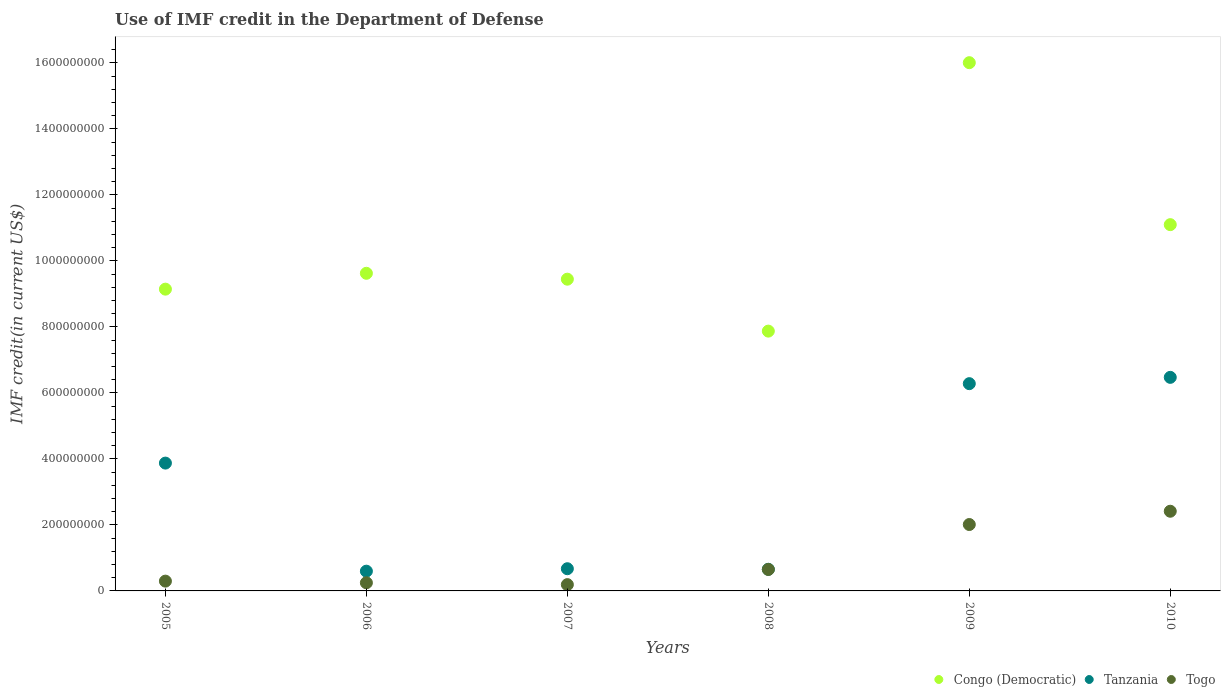What is the IMF credit in the Department of Defense in Togo in 2007?
Your response must be concise. 1.91e+07. Across all years, what is the maximum IMF credit in the Department of Defense in Congo (Democratic)?
Make the answer very short. 1.60e+09. Across all years, what is the minimum IMF credit in the Department of Defense in Togo?
Provide a short and direct response. 1.91e+07. In which year was the IMF credit in the Department of Defense in Tanzania maximum?
Keep it short and to the point. 2010. In which year was the IMF credit in the Department of Defense in Togo minimum?
Provide a succinct answer. 2007. What is the total IMF credit in the Department of Defense in Tanzania in the graph?
Your response must be concise. 1.86e+09. What is the difference between the IMF credit in the Department of Defense in Togo in 2007 and that in 2008?
Your answer should be very brief. -4.60e+07. What is the difference between the IMF credit in the Department of Defense in Togo in 2009 and the IMF credit in the Department of Defense in Tanzania in 2008?
Provide a succinct answer. 1.36e+08. What is the average IMF credit in the Department of Defense in Tanzania per year?
Your answer should be compact. 3.09e+08. In the year 2006, what is the difference between the IMF credit in the Department of Defense in Tanzania and IMF credit in the Department of Defense in Togo?
Your answer should be very brief. 3.52e+07. What is the ratio of the IMF credit in the Department of Defense in Congo (Democratic) in 2007 to that in 2010?
Provide a short and direct response. 0.85. Is the difference between the IMF credit in the Department of Defense in Tanzania in 2006 and 2007 greater than the difference between the IMF credit in the Department of Defense in Togo in 2006 and 2007?
Your response must be concise. No. What is the difference between the highest and the second highest IMF credit in the Department of Defense in Congo (Democratic)?
Offer a very short reply. 4.91e+08. What is the difference between the highest and the lowest IMF credit in the Department of Defense in Tanzania?
Offer a terse response. 5.87e+08. Is the sum of the IMF credit in the Department of Defense in Congo (Democratic) in 2005 and 2006 greater than the maximum IMF credit in the Department of Defense in Tanzania across all years?
Ensure brevity in your answer.  Yes. Is it the case that in every year, the sum of the IMF credit in the Department of Defense in Togo and IMF credit in the Department of Defense in Congo (Democratic)  is greater than the IMF credit in the Department of Defense in Tanzania?
Your response must be concise. Yes. How many dotlines are there?
Your response must be concise. 3. How many years are there in the graph?
Your response must be concise. 6. Does the graph contain any zero values?
Provide a short and direct response. No. Where does the legend appear in the graph?
Offer a terse response. Bottom right. How many legend labels are there?
Your response must be concise. 3. What is the title of the graph?
Offer a terse response. Use of IMF credit in the Department of Defense. Does "Guinea-Bissau" appear as one of the legend labels in the graph?
Your answer should be very brief. No. What is the label or title of the Y-axis?
Make the answer very short. IMF credit(in current US$). What is the IMF credit(in current US$) in Congo (Democratic) in 2005?
Offer a very short reply. 9.14e+08. What is the IMF credit(in current US$) of Tanzania in 2005?
Offer a terse response. 3.87e+08. What is the IMF credit(in current US$) in Togo in 2005?
Your response must be concise. 2.97e+07. What is the IMF credit(in current US$) of Congo (Democratic) in 2006?
Give a very brief answer. 9.62e+08. What is the IMF credit(in current US$) of Tanzania in 2006?
Offer a very short reply. 5.98e+07. What is the IMF credit(in current US$) of Togo in 2006?
Offer a terse response. 2.47e+07. What is the IMF credit(in current US$) of Congo (Democratic) in 2007?
Ensure brevity in your answer.  9.45e+08. What is the IMF credit(in current US$) in Tanzania in 2007?
Provide a succinct answer. 6.73e+07. What is the IMF credit(in current US$) in Togo in 2007?
Your answer should be compact. 1.91e+07. What is the IMF credit(in current US$) of Congo (Democratic) in 2008?
Offer a very short reply. 7.87e+08. What is the IMF credit(in current US$) of Tanzania in 2008?
Provide a short and direct response. 6.56e+07. What is the IMF credit(in current US$) in Togo in 2008?
Your answer should be compact. 6.50e+07. What is the IMF credit(in current US$) of Congo (Democratic) in 2009?
Offer a very short reply. 1.60e+09. What is the IMF credit(in current US$) of Tanzania in 2009?
Your response must be concise. 6.28e+08. What is the IMF credit(in current US$) of Togo in 2009?
Make the answer very short. 2.01e+08. What is the IMF credit(in current US$) in Congo (Democratic) in 2010?
Offer a terse response. 1.11e+09. What is the IMF credit(in current US$) in Tanzania in 2010?
Provide a short and direct response. 6.47e+08. What is the IMF credit(in current US$) of Togo in 2010?
Provide a succinct answer. 2.41e+08. Across all years, what is the maximum IMF credit(in current US$) of Congo (Democratic)?
Offer a very short reply. 1.60e+09. Across all years, what is the maximum IMF credit(in current US$) of Tanzania?
Ensure brevity in your answer.  6.47e+08. Across all years, what is the maximum IMF credit(in current US$) of Togo?
Your answer should be compact. 2.41e+08. Across all years, what is the minimum IMF credit(in current US$) of Congo (Democratic)?
Offer a very short reply. 7.87e+08. Across all years, what is the minimum IMF credit(in current US$) of Tanzania?
Your answer should be very brief. 5.98e+07. Across all years, what is the minimum IMF credit(in current US$) of Togo?
Keep it short and to the point. 1.91e+07. What is the total IMF credit(in current US$) of Congo (Democratic) in the graph?
Your answer should be very brief. 6.32e+09. What is the total IMF credit(in current US$) in Tanzania in the graph?
Provide a succinct answer. 1.86e+09. What is the total IMF credit(in current US$) in Togo in the graph?
Your answer should be very brief. 5.81e+08. What is the difference between the IMF credit(in current US$) of Congo (Democratic) in 2005 and that in 2006?
Keep it short and to the point. -4.81e+07. What is the difference between the IMF credit(in current US$) in Tanzania in 2005 and that in 2006?
Give a very brief answer. 3.28e+08. What is the difference between the IMF credit(in current US$) of Togo in 2005 and that in 2006?
Your answer should be compact. 4.98e+06. What is the difference between the IMF credit(in current US$) in Congo (Democratic) in 2005 and that in 2007?
Make the answer very short. -3.02e+07. What is the difference between the IMF credit(in current US$) in Tanzania in 2005 and that in 2007?
Your answer should be very brief. 3.20e+08. What is the difference between the IMF credit(in current US$) of Togo in 2005 and that in 2007?
Provide a succinct answer. 1.06e+07. What is the difference between the IMF credit(in current US$) in Congo (Democratic) in 2005 and that in 2008?
Your response must be concise. 1.27e+08. What is the difference between the IMF credit(in current US$) of Tanzania in 2005 and that in 2008?
Ensure brevity in your answer.  3.22e+08. What is the difference between the IMF credit(in current US$) in Togo in 2005 and that in 2008?
Provide a succinct answer. -3.54e+07. What is the difference between the IMF credit(in current US$) in Congo (Democratic) in 2005 and that in 2009?
Your answer should be compact. -6.86e+08. What is the difference between the IMF credit(in current US$) of Tanzania in 2005 and that in 2009?
Offer a terse response. -2.41e+08. What is the difference between the IMF credit(in current US$) in Togo in 2005 and that in 2009?
Make the answer very short. -1.72e+08. What is the difference between the IMF credit(in current US$) of Congo (Democratic) in 2005 and that in 2010?
Your answer should be very brief. -1.95e+08. What is the difference between the IMF credit(in current US$) of Tanzania in 2005 and that in 2010?
Make the answer very short. -2.60e+08. What is the difference between the IMF credit(in current US$) of Togo in 2005 and that in 2010?
Offer a terse response. -2.12e+08. What is the difference between the IMF credit(in current US$) in Congo (Democratic) in 2006 and that in 2007?
Your response must be concise. 1.78e+07. What is the difference between the IMF credit(in current US$) of Tanzania in 2006 and that in 2007?
Your answer should be very brief. -7.44e+06. What is the difference between the IMF credit(in current US$) in Togo in 2006 and that in 2007?
Ensure brevity in your answer.  5.62e+06. What is the difference between the IMF credit(in current US$) in Congo (Democratic) in 2006 and that in 2008?
Offer a terse response. 1.75e+08. What is the difference between the IMF credit(in current US$) of Tanzania in 2006 and that in 2008?
Your answer should be very brief. -5.74e+06. What is the difference between the IMF credit(in current US$) of Togo in 2006 and that in 2008?
Give a very brief answer. -4.03e+07. What is the difference between the IMF credit(in current US$) in Congo (Democratic) in 2006 and that in 2009?
Offer a terse response. -6.38e+08. What is the difference between the IMF credit(in current US$) in Tanzania in 2006 and that in 2009?
Provide a short and direct response. -5.68e+08. What is the difference between the IMF credit(in current US$) of Togo in 2006 and that in 2009?
Make the answer very short. -1.77e+08. What is the difference between the IMF credit(in current US$) in Congo (Democratic) in 2006 and that in 2010?
Give a very brief answer. -1.47e+08. What is the difference between the IMF credit(in current US$) of Tanzania in 2006 and that in 2010?
Make the answer very short. -5.87e+08. What is the difference between the IMF credit(in current US$) of Togo in 2006 and that in 2010?
Provide a succinct answer. -2.17e+08. What is the difference between the IMF credit(in current US$) in Congo (Democratic) in 2007 and that in 2008?
Offer a terse response. 1.57e+08. What is the difference between the IMF credit(in current US$) of Tanzania in 2007 and that in 2008?
Offer a terse response. 1.70e+06. What is the difference between the IMF credit(in current US$) of Togo in 2007 and that in 2008?
Offer a terse response. -4.60e+07. What is the difference between the IMF credit(in current US$) of Congo (Democratic) in 2007 and that in 2009?
Ensure brevity in your answer.  -6.56e+08. What is the difference between the IMF credit(in current US$) of Tanzania in 2007 and that in 2009?
Give a very brief answer. -5.61e+08. What is the difference between the IMF credit(in current US$) of Togo in 2007 and that in 2009?
Provide a succinct answer. -1.82e+08. What is the difference between the IMF credit(in current US$) of Congo (Democratic) in 2007 and that in 2010?
Provide a short and direct response. -1.65e+08. What is the difference between the IMF credit(in current US$) in Tanzania in 2007 and that in 2010?
Give a very brief answer. -5.80e+08. What is the difference between the IMF credit(in current US$) of Togo in 2007 and that in 2010?
Ensure brevity in your answer.  -2.22e+08. What is the difference between the IMF credit(in current US$) of Congo (Democratic) in 2008 and that in 2009?
Provide a short and direct response. -8.13e+08. What is the difference between the IMF credit(in current US$) in Tanzania in 2008 and that in 2009?
Ensure brevity in your answer.  -5.62e+08. What is the difference between the IMF credit(in current US$) in Togo in 2008 and that in 2009?
Provide a succinct answer. -1.36e+08. What is the difference between the IMF credit(in current US$) of Congo (Democratic) in 2008 and that in 2010?
Give a very brief answer. -3.23e+08. What is the difference between the IMF credit(in current US$) of Tanzania in 2008 and that in 2010?
Offer a very short reply. -5.82e+08. What is the difference between the IMF credit(in current US$) of Togo in 2008 and that in 2010?
Offer a very short reply. -1.76e+08. What is the difference between the IMF credit(in current US$) in Congo (Democratic) in 2009 and that in 2010?
Provide a short and direct response. 4.91e+08. What is the difference between the IMF credit(in current US$) of Tanzania in 2009 and that in 2010?
Give a very brief answer. -1.91e+07. What is the difference between the IMF credit(in current US$) of Togo in 2009 and that in 2010?
Your answer should be very brief. -4.03e+07. What is the difference between the IMF credit(in current US$) in Congo (Democratic) in 2005 and the IMF credit(in current US$) in Tanzania in 2006?
Offer a terse response. 8.55e+08. What is the difference between the IMF credit(in current US$) in Congo (Democratic) in 2005 and the IMF credit(in current US$) in Togo in 2006?
Your answer should be very brief. 8.90e+08. What is the difference between the IMF credit(in current US$) in Tanzania in 2005 and the IMF credit(in current US$) in Togo in 2006?
Ensure brevity in your answer.  3.63e+08. What is the difference between the IMF credit(in current US$) in Congo (Democratic) in 2005 and the IMF credit(in current US$) in Tanzania in 2007?
Offer a very short reply. 8.47e+08. What is the difference between the IMF credit(in current US$) of Congo (Democratic) in 2005 and the IMF credit(in current US$) of Togo in 2007?
Keep it short and to the point. 8.95e+08. What is the difference between the IMF credit(in current US$) of Tanzania in 2005 and the IMF credit(in current US$) of Togo in 2007?
Make the answer very short. 3.68e+08. What is the difference between the IMF credit(in current US$) of Congo (Democratic) in 2005 and the IMF credit(in current US$) of Tanzania in 2008?
Offer a terse response. 8.49e+08. What is the difference between the IMF credit(in current US$) in Congo (Democratic) in 2005 and the IMF credit(in current US$) in Togo in 2008?
Provide a short and direct response. 8.49e+08. What is the difference between the IMF credit(in current US$) in Tanzania in 2005 and the IMF credit(in current US$) in Togo in 2008?
Your answer should be compact. 3.22e+08. What is the difference between the IMF credit(in current US$) in Congo (Democratic) in 2005 and the IMF credit(in current US$) in Tanzania in 2009?
Ensure brevity in your answer.  2.86e+08. What is the difference between the IMF credit(in current US$) in Congo (Democratic) in 2005 and the IMF credit(in current US$) in Togo in 2009?
Provide a short and direct response. 7.13e+08. What is the difference between the IMF credit(in current US$) in Tanzania in 2005 and the IMF credit(in current US$) in Togo in 2009?
Offer a terse response. 1.86e+08. What is the difference between the IMF credit(in current US$) in Congo (Democratic) in 2005 and the IMF credit(in current US$) in Tanzania in 2010?
Provide a short and direct response. 2.67e+08. What is the difference between the IMF credit(in current US$) of Congo (Democratic) in 2005 and the IMF credit(in current US$) of Togo in 2010?
Provide a short and direct response. 6.73e+08. What is the difference between the IMF credit(in current US$) of Tanzania in 2005 and the IMF credit(in current US$) of Togo in 2010?
Keep it short and to the point. 1.46e+08. What is the difference between the IMF credit(in current US$) of Congo (Democratic) in 2006 and the IMF credit(in current US$) of Tanzania in 2007?
Give a very brief answer. 8.95e+08. What is the difference between the IMF credit(in current US$) in Congo (Democratic) in 2006 and the IMF credit(in current US$) in Togo in 2007?
Offer a very short reply. 9.43e+08. What is the difference between the IMF credit(in current US$) of Tanzania in 2006 and the IMF credit(in current US$) of Togo in 2007?
Your answer should be very brief. 4.08e+07. What is the difference between the IMF credit(in current US$) in Congo (Democratic) in 2006 and the IMF credit(in current US$) in Tanzania in 2008?
Offer a terse response. 8.97e+08. What is the difference between the IMF credit(in current US$) in Congo (Democratic) in 2006 and the IMF credit(in current US$) in Togo in 2008?
Give a very brief answer. 8.97e+08. What is the difference between the IMF credit(in current US$) in Tanzania in 2006 and the IMF credit(in current US$) in Togo in 2008?
Keep it short and to the point. -5.18e+06. What is the difference between the IMF credit(in current US$) of Congo (Democratic) in 2006 and the IMF credit(in current US$) of Tanzania in 2009?
Your answer should be very brief. 3.34e+08. What is the difference between the IMF credit(in current US$) of Congo (Democratic) in 2006 and the IMF credit(in current US$) of Togo in 2009?
Your response must be concise. 7.61e+08. What is the difference between the IMF credit(in current US$) of Tanzania in 2006 and the IMF credit(in current US$) of Togo in 2009?
Your answer should be very brief. -1.41e+08. What is the difference between the IMF credit(in current US$) in Congo (Democratic) in 2006 and the IMF credit(in current US$) in Tanzania in 2010?
Ensure brevity in your answer.  3.15e+08. What is the difference between the IMF credit(in current US$) of Congo (Democratic) in 2006 and the IMF credit(in current US$) of Togo in 2010?
Offer a terse response. 7.21e+08. What is the difference between the IMF credit(in current US$) of Tanzania in 2006 and the IMF credit(in current US$) of Togo in 2010?
Keep it short and to the point. -1.82e+08. What is the difference between the IMF credit(in current US$) of Congo (Democratic) in 2007 and the IMF credit(in current US$) of Tanzania in 2008?
Offer a terse response. 8.79e+08. What is the difference between the IMF credit(in current US$) in Congo (Democratic) in 2007 and the IMF credit(in current US$) in Togo in 2008?
Keep it short and to the point. 8.80e+08. What is the difference between the IMF credit(in current US$) of Tanzania in 2007 and the IMF credit(in current US$) of Togo in 2008?
Give a very brief answer. 2.26e+06. What is the difference between the IMF credit(in current US$) of Congo (Democratic) in 2007 and the IMF credit(in current US$) of Tanzania in 2009?
Make the answer very short. 3.17e+08. What is the difference between the IMF credit(in current US$) of Congo (Democratic) in 2007 and the IMF credit(in current US$) of Togo in 2009?
Provide a succinct answer. 7.43e+08. What is the difference between the IMF credit(in current US$) of Tanzania in 2007 and the IMF credit(in current US$) of Togo in 2009?
Provide a short and direct response. -1.34e+08. What is the difference between the IMF credit(in current US$) in Congo (Democratic) in 2007 and the IMF credit(in current US$) in Tanzania in 2010?
Give a very brief answer. 2.97e+08. What is the difference between the IMF credit(in current US$) of Congo (Democratic) in 2007 and the IMF credit(in current US$) of Togo in 2010?
Give a very brief answer. 7.03e+08. What is the difference between the IMF credit(in current US$) of Tanzania in 2007 and the IMF credit(in current US$) of Togo in 2010?
Keep it short and to the point. -1.74e+08. What is the difference between the IMF credit(in current US$) in Congo (Democratic) in 2008 and the IMF credit(in current US$) in Tanzania in 2009?
Provide a short and direct response. 1.59e+08. What is the difference between the IMF credit(in current US$) in Congo (Democratic) in 2008 and the IMF credit(in current US$) in Togo in 2009?
Make the answer very short. 5.86e+08. What is the difference between the IMF credit(in current US$) of Tanzania in 2008 and the IMF credit(in current US$) of Togo in 2009?
Offer a very short reply. -1.36e+08. What is the difference between the IMF credit(in current US$) in Congo (Democratic) in 2008 and the IMF credit(in current US$) in Tanzania in 2010?
Your answer should be very brief. 1.40e+08. What is the difference between the IMF credit(in current US$) in Congo (Democratic) in 2008 and the IMF credit(in current US$) in Togo in 2010?
Provide a succinct answer. 5.46e+08. What is the difference between the IMF credit(in current US$) of Tanzania in 2008 and the IMF credit(in current US$) of Togo in 2010?
Give a very brief answer. -1.76e+08. What is the difference between the IMF credit(in current US$) in Congo (Democratic) in 2009 and the IMF credit(in current US$) in Tanzania in 2010?
Give a very brief answer. 9.54e+08. What is the difference between the IMF credit(in current US$) of Congo (Democratic) in 2009 and the IMF credit(in current US$) of Togo in 2010?
Provide a short and direct response. 1.36e+09. What is the difference between the IMF credit(in current US$) in Tanzania in 2009 and the IMF credit(in current US$) in Togo in 2010?
Your answer should be compact. 3.87e+08. What is the average IMF credit(in current US$) of Congo (Democratic) per year?
Provide a succinct answer. 1.05e+09. What is the average IMF credit(in current US$) of Tanzania per year?
Ensure brevity in your answer.  3.09e+08. What is the average IMF credit(in current US$) in Togo per year?
Your answer should be compact. 9.68e+07. In the year 2005, what is the difference between the IMF credit(in current US$) of Congo (Democratic) and IMF credit(in current US$) of Tanzania?
Give a very brief answer. 5.27e+08. In the year 2005, what is the difference between the IMF credit(in current US$) in Congo (Democratic) and IMF credit(in current US$) in Togo?
Keep it short and to the point. 8.85e+08. In the year 2005, what is the difference between the IMF credit(in current US$) in Tanzania and IMF credit(in current US$) in Togo?
Provide a short and direct response. 3.58e+08. In the year 2006, what is the difference between the IMF credit(in current US$) of Congo (Democratic) and IMF credit(in current US$) of Tanzania?
Offer a terse response. 9.03e+08. In the year 2006, what is the difference between the IMF credit(in current US$) of Congo (Democratic) and IMF credit(in current US$) of Togo?
Provide a short and direct response. 9.38e+08. In the year 2006, what is the difference between the IMF credit(in current US$) of Tanzania and IMF credit(in current US$) of Togo?
Ensure brevity in your answer.  3.52e+07. In the year 2007, what is the difference between the IMF credit(in current US$) of Congo (Democratic) and IMF credit(in current US$) of Tanzania?
Give a very brief answer. 8.77e+08. In the year 2007, what is the difference between the IMF credit(in current US$) of Congo (Democratic) and IMF credit(in current US$) of Togo?
Your answer should be very brief. 9.26e+08. In the year 2007, what is the difference between the IMF credit(in current US$) of Tanzania and IMF credit(in current US$) of Togo?
Give a very brief answer. 4.82e+07. In the year 2008, what is the difference between the IMF credit(in current US$) in Congo (Democratic) and IMF credit(in current US$) in Tanzania?
Offer a very short reply. 7.22e+08. In the year 2008, what is the difference between the IMF credit(in current US$) in Congo (Democratic) and IMF credit(in current US$) in Togo?
Make the answer very short. 7.22e+08. In the year 2008, what is the difference between the IMF credit(in current US$) in Tanzania and IMF credit(in current US$) in Togo?
Provide a short and direct response. 5.58e+05. In the year 2009, what is the difference between the IMF credit(in current US$) of Congo (Democratic) and IMF credit(in current US$) of Tanzania?
Keep it short and to the point. 9.73e+08. In the year 2009, what is the difference between the IMF credit(in current US$) in Congo (Democratic) and IMF credit(in current US$) in Togo?
Offer a very short reply. 1.40e+09. In the year 2009, what is the difference between the IMF credit(in current US$) in Tanzania and IMF credit(in current US$) in Togo?
Provide a succinct answer. 4.27e+08. In the year 2010, what is the difference between the IMF credit(in current US$) in Congo (Democratic) and IMF credit(in current US$) in Tanzania?
Offer a very short reply. 4.63e+08. In the year 2010, what is the difference between the IMF credit(in current US$) of Congo (Democratic) and IMF credit(in current US$) of Togo?
Give a very brief answer. 8.68e+08. In the year 2010, what is the difference between the IMF credit(in current US$) of Tanzania and IMF credit(in current US$) of Togo?
Make the answer very short. 4.06e+08. What is the ratio of the IMF credit(in current US$) in Congo (Democratic) in 2005 to that in 2006?
Your response must be concise. 0.95. What is the ratio of the IMF credit(in current US$) in Tanzania in 2005 to that in 2006?
Make the answer very short. 6.47. What is the ratio of the IMF credit(in current US$) in Togo in 2005 to that in 2006?
Offer a terse response. 1.2. What is the ratio of the IMF credit(in current US$) of Congo (Democratic) in 2005 to that in 2007?
Offer a terse response. 0.97. What is the ratio of the IMF credit(in current US$) of Tanzania in 2005 to that in 2007?
Offer a very short reply. 5.76. What is the ratio of the IMF credit(in current US$) in Togo in 2005 to that in 2007?
Provide a short and direct response. 1.56. What is the ratio of the IMF credit(in current US$) in Congo (Democratic) in 2005 to that in 2008?
Provide a succinct answer. 1.16. What is the ratio of the IMF credit(in current US$) in Tanzania in 2005 to that in 2008?
Provide a short and direct response. 5.91. What is the ratio of the IMF credit(in current US$) in Togo in 2005 to that in 2008?
Offer a terse response. 0.46. What is the ratio of the IMF credit(in current US$) of Congo (Democratic) in 2005 to that in 2009?
Keep it short and to the point. 0.57. What is the ratio of the IMF credit(in current US$) of Tanzania in 2005 to that in 2009?
Make the answer very short. 0.62. What is the ratio of the IMF credit(in current US$) of Togo in 2005 to that in 2009?
Offer a terse response. 0.15. What is the ratio of the IMF credit(in current US$) in Congo (Democratic) in 2005 to that in 2010?
Keep it short and to the point. 0.82. What is the ratio of the IMF credit(in current US$) in Tanzania in 2005 to that in 2010?
Ensure brevity in your answer.  0.6. What is the ratio of the IMF credit(in current US$) of Togo in 2005 to that in 2010?
Provide a succinct answer. 0.12. What is the ratio of the IMF credit(in current US$) of Congo (Democratic) in 2006 to that in 2007?
Offer a very short reply. 1.02. What is the ratio of the IMF credit(in current US$) in Tanzania in 2006 to that in 2007?
Your response must be concise. 0.89. What is the ratio of the IMF credit(in current US$) of Togo in 2006 to that in 2007?
Make the answer very short. 1.29. What is the ratio of the IMF credit(in current US$) in Congo (Democratic) in 2006 to that in 2008?
Ensure brevity in your answer.  1.22. What is the ratio of the IMF credit(in current US$) of Tanzania in 2006 to that in 2008?
Give a very brief answer. 0.91. What is the ratio of the IMF credit(in current US$) of Togo in 2006 to that in 2008?
Your answer should be compact. 0.38. What is the ratio of the IMF credit(in current US$) of Congo (Democratic) in 2006 to that in 2009?
Offer a very short reply. 0.6. What is the ratio of the IMF credit(in current US$) of Tanzania in 2006 to that in 2009?
Make the answer very short. 0.1. What is the ratio of the IMF credit(in current US$) in Togo in 2006 to that in 2009?
Provide a short and direct response. 0.12. What is the ratio of the IMF credit(in current US$) in Congo (Democratic) in 2006 to that in 2010?
Provide a succinct answer. 0.87. What is the ratio of the IMF credit(in current US$) of Tanzania in 2006 to that in 2010?
Your response must be concise. 0.09. What is the ratio of the IMF credit(in current US$) in Togo in 2006 to that in 2010?
Offer a very short reply. 0.1. What is the ratio of the IMF credit(in current US$) of Congo (Democratic) in 2007 to that in 2008?
Your answer should be very brief. 1.2. What is the ratio of the IMF credit(in current US$) of Togo in 2007 to that in 2008?
Make the answer very short. 0.29. What is the ratio of the IMF credit(in current US$) in Congo (Democratic) in 2007 to that in 2009?
Your answer should be very brief. 0.59. What is the ratio of the IMF credit(in current US$) in Tanzania in 2007 to that in 2009?
Offer a terse response. 0.11. What is the ratio of the IMF credit(in current US$) of Togo in 2007 to that in 2009?
Give a very brief answer. 0.09. What is the ratio of the IMF credit(in current US$) in Congo (Democratic) in 2007 to that in 2010?
Give a very brief answer. 0.85. What is the ratio of the IMF credit(in current US$) of Tanzania in 2007 to that in 2010?
Ensure brevity in your answer.  0.1. What is the ratio of the IMF credit(in current US$) in Togo in 2007 to that in 2010?
Ensure brevity in your answer.  0.08. What is the ratio of the IMF credit(in current US$) in Congo (Democratic) in 2008 to that in 2009?
Keep it short and to the point. 0.49. What is the ratio of the IMF credit(in current US$) in Tanzania in 2008 to that in 2009?
Make the answer very short. 0.1. What is the ratio of the IMF credit(in current US$) in Togo in 2008 to that in 2009?
Give a very brief answer. 0.32. What is the ratio of the IMF credit(in current US$) in Congo (Democratic) in 2008 to that in 2010?
Your answer should be very brief. 0.71. What is the ratio of the IMF credit(in current US$) of Tanzania in 2008 to that in 2010?
Offer a terse response. 0.1. What is the ratio of the IMF credit(in current US$) of Togo in 2008 to that in 2010?
Your answer should be very brief. 0.27. What is the ratio of the IMF credit(in current US$) in Congo (Democratic) in 2009 to that in 2010?
Offer a very short reply. 1.44. What is the ratio of the IMF credit(in current US$) of Tanzania in 2009 to that in 2010?
Provide a short and direct response. 0.97. What is the difference between the highest and the second highest IMF credit(in current US$) in Congo (Democratic)?
Your answer should be compact. 4.91e+08. What is the difference between the highest and the second highest IMF credit(in current US$) of Tanzania?
Ensure brevity in your answer.  1.91e+07. What is the difference between the highest and the second highest IMF credit(in current US$) of Togo?
Provide a short and direct response. 4.03e+07. What is the difference between the highest and the lowest IMF credit(in current US$) in Congo (Democratic)?
Keep it short and to the point. 8.13e+08. What is the difference between the highest and the lowest IMF credit(in current US$) of Tanzania?
Offer a very short reply. 5.87e+08. What is the difference between the highest and the lowest IMF credit(in current US$) of Togo?
Provide a succinct answer. 2.22e+08. 